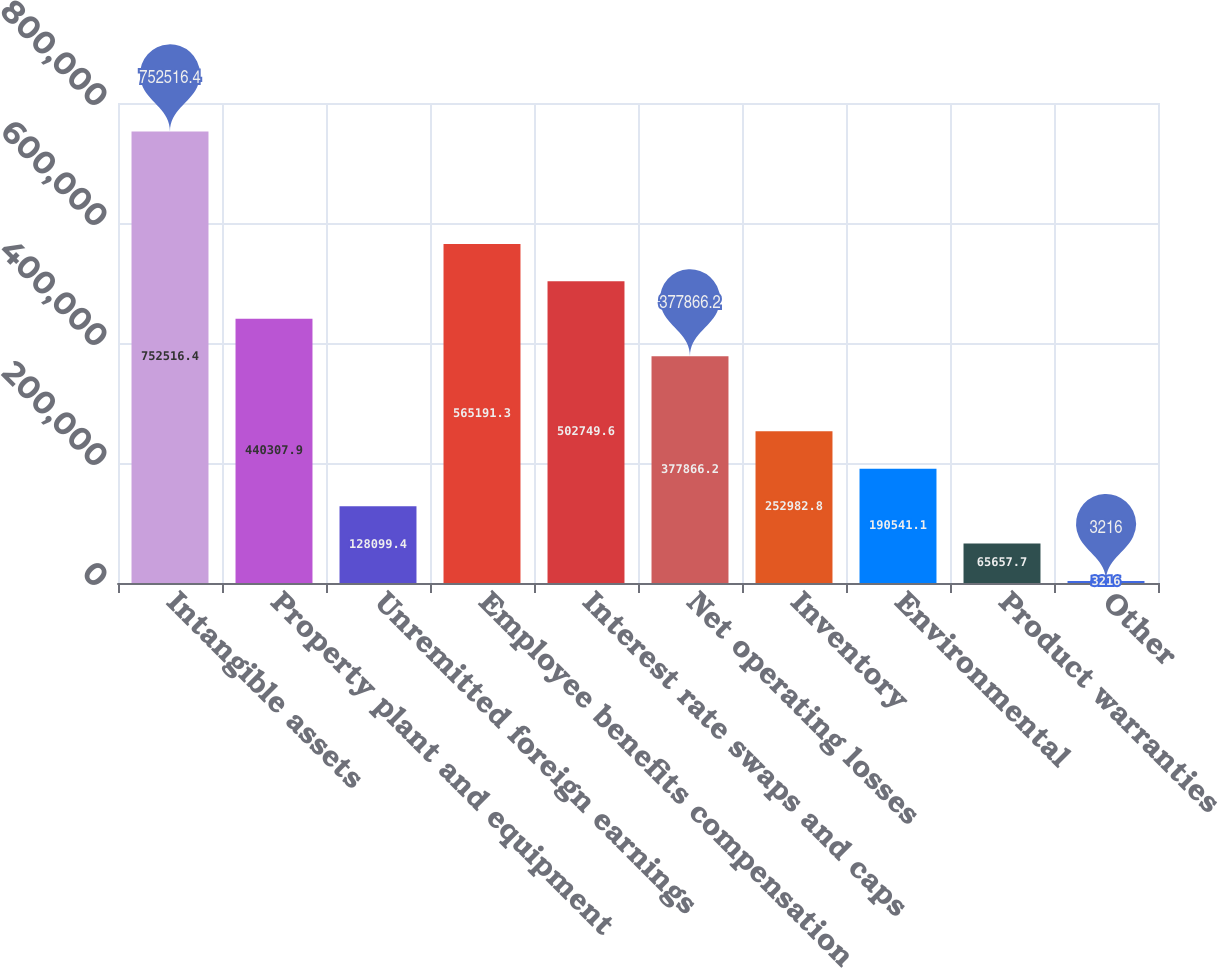Convert chart. <chart><loc_0><loc_0><loc_500><loc_500><bar_chart><fcel>Intangible assets<fcel>Property plant and equipment<fcel>Unremitted foreign earnings<fcel>Employee benefits compensation<fcel>Interest rate swaps and caps<fcel>Net operating losses<fcel>Inventory<fcel>Environmental<fcel>Product warranties<fcel>Other<nl><fcel>752516<fcel>440308<fcel>128099<fcel>565191<fcel>502750<fcel>377866<fcel>252983<fcel>190541<fcel>65657.7<fcel>3216<nl></chart> 